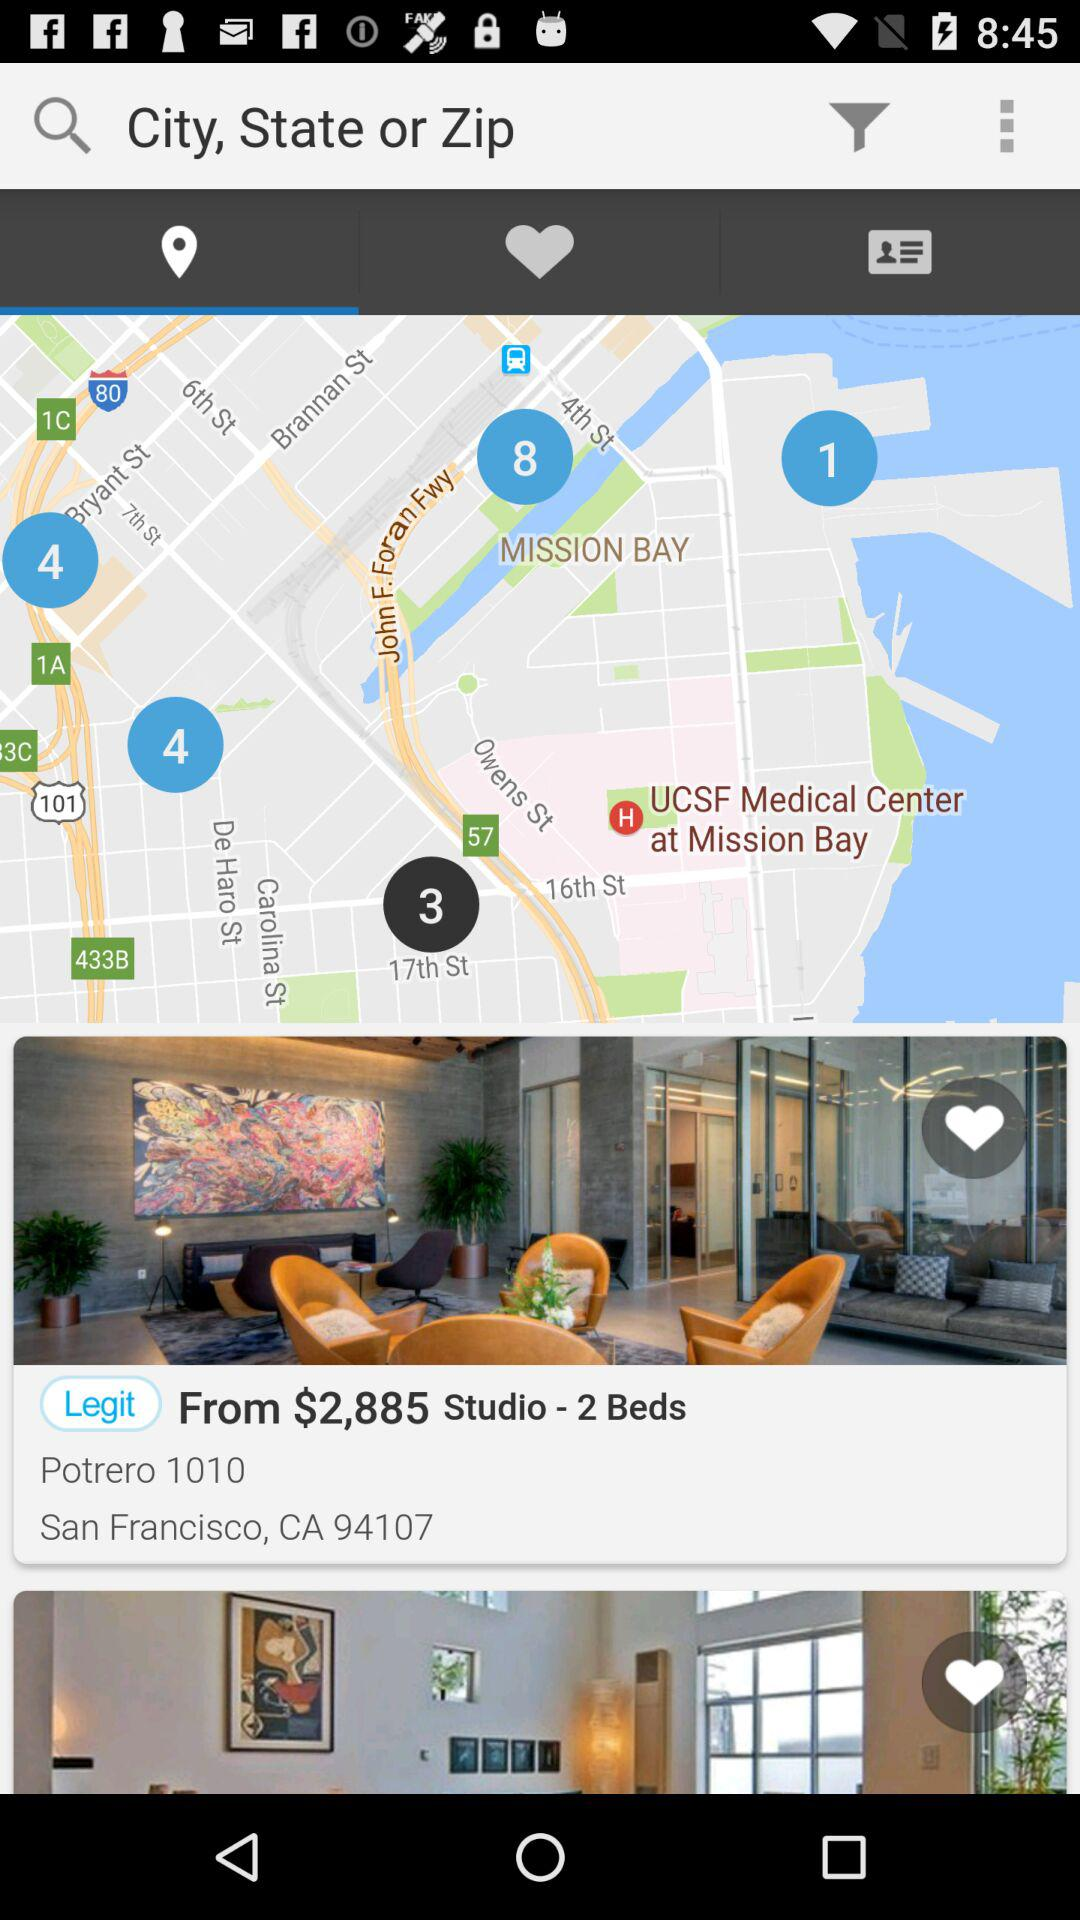How many beds are available in the studio? There are 2 beds available in the studio. 